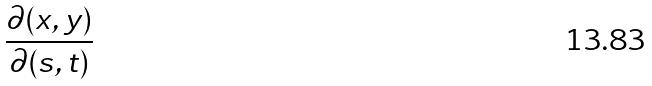Convert formula to latex. <formula><loc_0><loc_0><loc_500><loc_500>\frac { \partial ( x , y ) } { \partial ( s , t ) }</formula> 